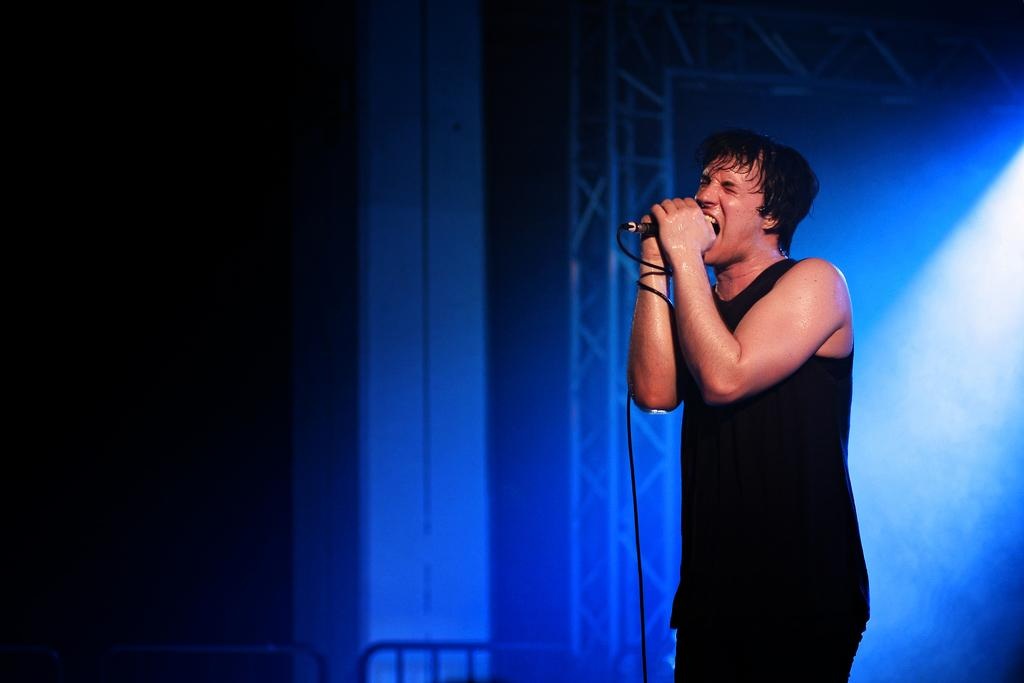Who is the main subject in the image? There is a man in the image. What is the man holding in the image? The man is holding a mic. What can be seen in the foreground of the image? There are objects in the foreground of the image. How would you describe the background of the image? The background of the image is dark. What type of farmer is leading the way in the image? There is no farmer or any indication of leading in the image; it features a man holding a mic. 